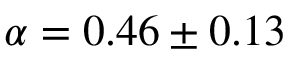<formula> <loc_0><loc_0><loc_500><loc_500>\alpha = 0 . 4 6 \pm 0 . 1 3</formula> 